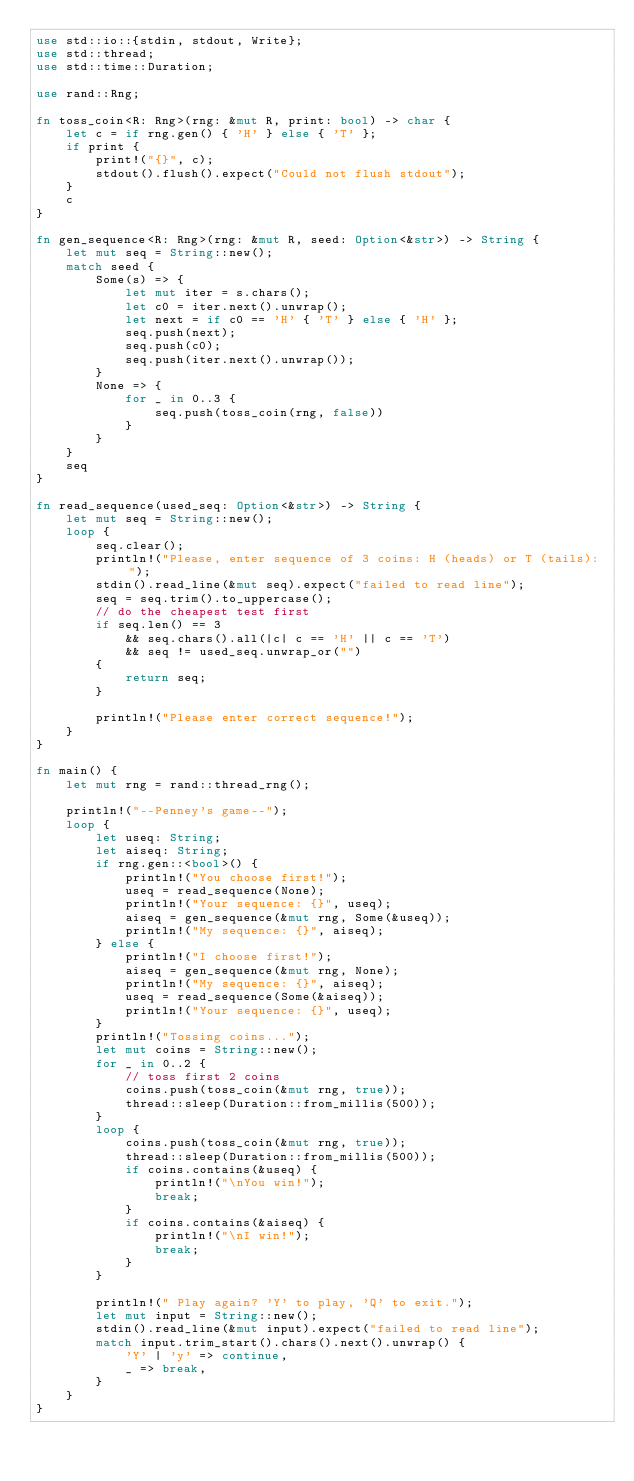Convert code to text. <code><loc_0><loc_0><loc_500><loc_500><_Rust_>use std::io::{stdin, stdout, Write};
use std::thread;
use std::time::Duration;

use rand::Rng;

fn toss_coin<R: Rng>(rng: &mut R, print: bool) -> char {
    let c = if rng.gen() { 'H' } else { 'T' };
    if print {
        print!("{}", c);
        stdout().flush().expect("Could not flush stdout");
    }
    c
}

fn gen_sequence<R: Rng>(rng: &mut R, seed: Option<&str>) -> String {
    let mut seq = String::new();
    match seed {
        Some(s) => {
            let mut iter = s.chars();
            let c0 = iter.next().unwrap();
            let next = if c0 == 'H' { 'T' } else { 'H' };
            seq.push(next);
            seq.push(c0);
            seq.push(iter.next().unwrap());
        }
        None => {
            for _ in 0..3 {
                seq.push(toss_coin(rng, false))
            }
        }
    }
    seq
}

fn read_sequence(used_seq: Option<&str>) -> String {
    let mut seq = String::new();
    loop {
        seq.clear();
        println!("Please, enter sequence of 3 coins: H (heads) or T (tails): ");
        stdin().read_line(&mut seq).expect("failed to read line");
        seq = seq.trim().to_uppercase();
        // do the cheapest test first
        if seq.len() == 3
            && seq.chars().all(|c| c == 'H' || c == 'T')
            && seq != used_seq.unwrap_or("")
        {
            return seq;
        }

        println!("Please enter correct sequence!");
    }
}

fn main() {
    let mut rng = rand::thread_rng();

    println!("--Penney's game--");
    loop {
        let useq: String;
        let aiseq: String;
        if rng.gen::<bool>() {
            println!("You choose first!");
            useq = read_sequence(None);
            println!("Your sequence: {}", useq);
            aiseq = gen_sequence(&mut rng, Some(&useq));
            println!("My sequence: {}", aiseq);
        } else {
            println!("I choose first!");
            aiseq = gen_sequence(&mut rng, None);
            println!("My sequence: {}", aiseq);
            useq = read_sequence(Some(&aiseq));
            println!("Your sequence: {}", useq);
        }
        println!("Tossing coins...");
        let mut coins = String::new();
        for _ in 0..2 {
            // toss first 2 coins
            coins.push(toss_coin(&mut rng, true));
            thread::sleep(Duration::from_millis(500));
        }
        loop {
            coins.push(toss_coin(&mut rng, true));
            thread::sleep(Duration::from_millis(500));
            if coins.contains(&useq) {
                println!("\nYou win!");
                break;
            }
            if coins.contains(&aiseq) {
                println!("\nI win!");
                break;
            }
        }

        println!(" Play again? 'Y' to play, 'Q' to exit.");
        let mut input = String::new();
        stdin().read_line(&mut input).expect("failed to read line");
        match input.trim_start().chars().next().unwrap() {
            'Y' | 'y' => continue,
            _ => break,
        }
    }
}
</code> 